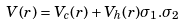Convert formula to latex. <formula><loc_0><loc_0><loc_500><loc_500>V ( r ) = V _ { c } ( r ) + V _ { h } ( r ) { \sigma _ { 1 } } . { \sigma _ { 2 } }</formula> 